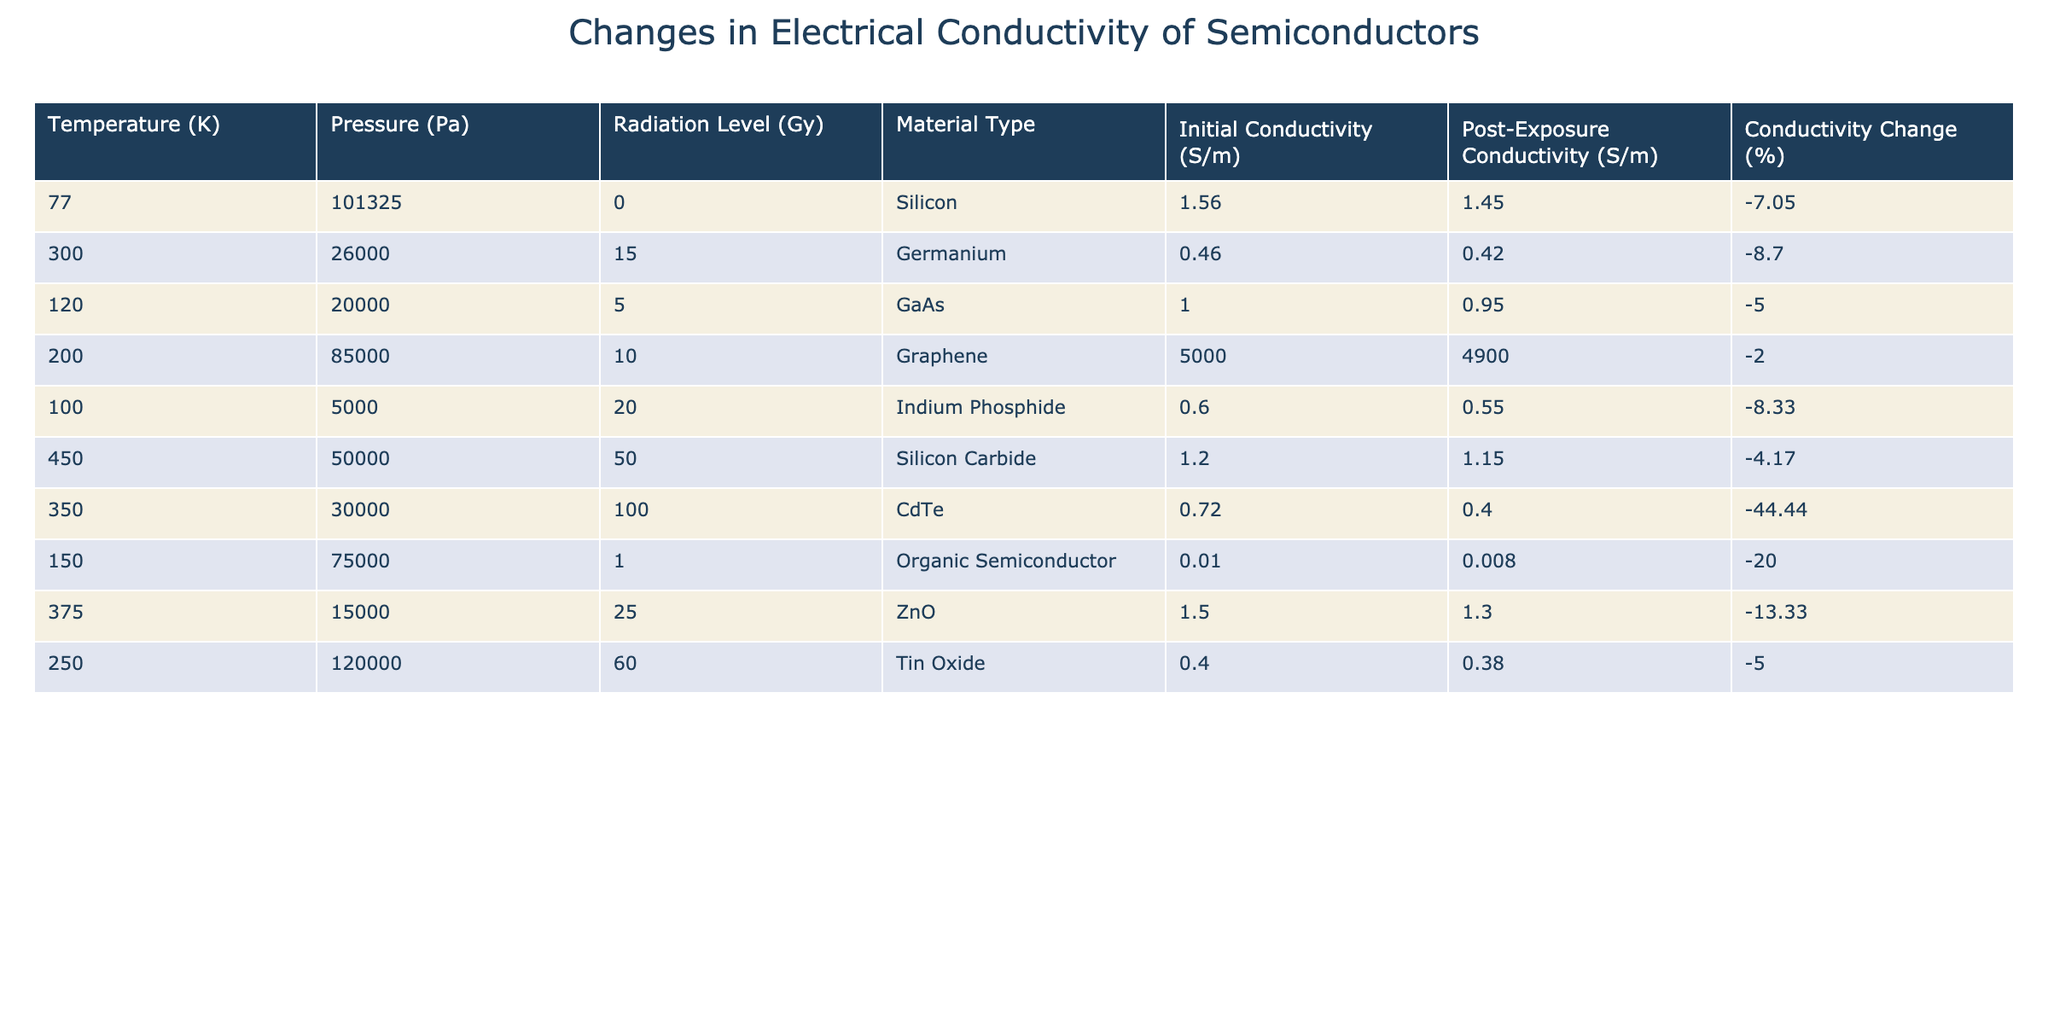What is the initial conductivity of Silicon? The table lists the initial conductivity values for various materials. For Silicon, the initial conductivity is reported as 1.56 S/m.
Answer: 1.56 S/m What is the highest percentage change in conductivity across all materials? By examining the percentage change data, the lowest value can be identified. The highest negative percentage change is for CdTe with -44.44%.
Answer: -44.44% Is the post-exposure conductivity of Germanium higher than that of GaAs? The post-exposure conductivity of Germanium is 0.42 S/m, while for GaAs it is 0.95 S/m. Since 0.42 S/m is less than 0.95 S/m, the statement is false.
Answer: No What is the conductivity change for Indium Phosphide? The table provides a direct percentage change for Indium Phosphide, which is -8.33%. This is the difference between its initial and post-exposure conductivity values.
Answer: -8.33% Which material has the second highest initial conductivity and what is its value? From the table, we can look at the initial conductivity values. Graphene has the highest conductivity of 5000 S/m, and the second highest is Silicon with 1.56 S/m.
Answer: 1.56 S/m What is the average post-exposure conductivity of all semiconductors listed? To find the average, we sum the post-exposure conductivities: 1.45 + 0.42 + 0.95 + 4900 + 0.55 + 1.15 + 0.40 + 0.008 + 1.3 + 0.38 = 4906.6. Then we divide by 10 (the number of materials), resulting in an average of 490.66 S/m.
Answer: 490.66 S/m Has any material experienced less than -10% change in conductivity? To determine this, we check each percentage change listed in the table. We find several materials, including Graphene with -2.00%, which is indeed more than -10%. Thus, yes, there are materials with less than -10% change.
Answer: Yes What is the difference in initial conductivity between CdTe and ZnO? The initial conductivity of CdTe is 0.72 S/m and for ZnO it is 1.5 S/m. The difference is 1.5 - 0.72 = 0.78 S/m.
Answer: 0.78 S/m Which material, under the highest temperature condition, has the least conductivity change? We look at the material under the maximum temperature of 450 K, which is Silicon Carbide showing a conductivity change of -4.17%, and then compare it to others, affirmatively noting it's the least.
Answer: -4.17% 